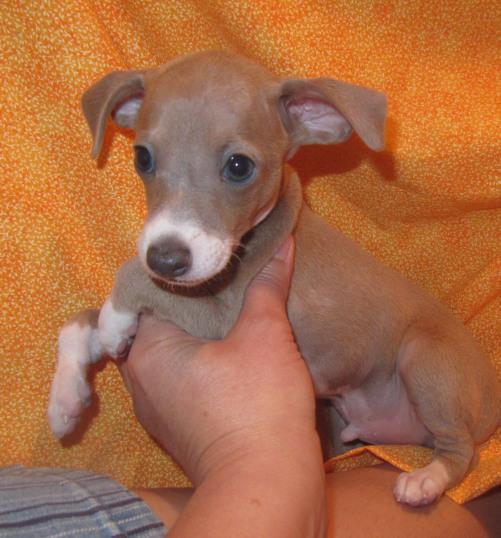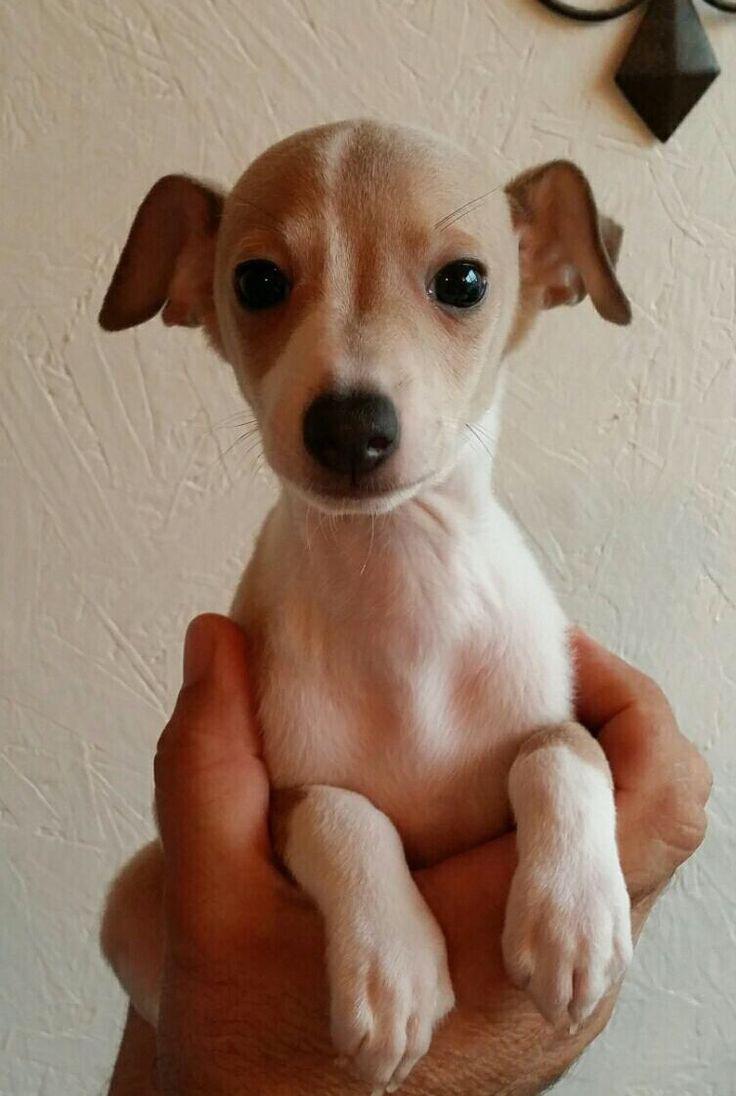The first image is the image on the left, the second image is the image on the right. Considering the images on both sides, is "There is at least five dogs." valid? Answer yes or no. No. The first image is the image on the left, the second image is the image on the right. Considering the images on both sides, is "A person is holding the dog in the image on the left." valid? Answer yes or no. Yes. 